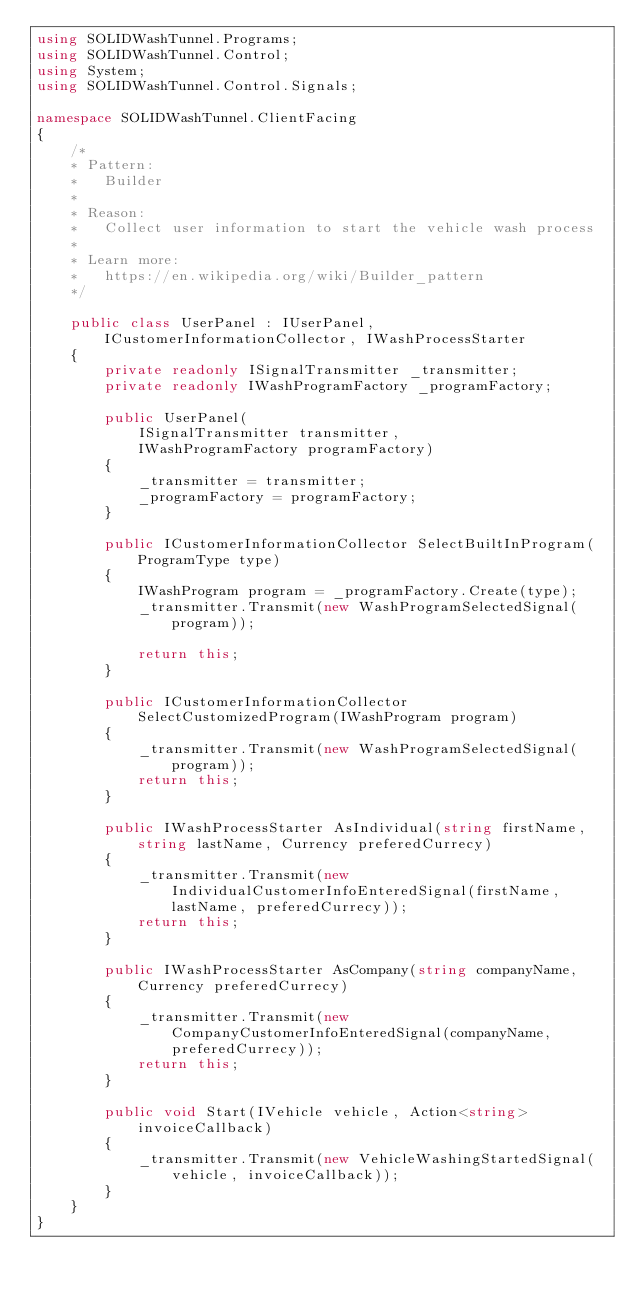<code> <loc_0><loc_0><loc_500><loc_500><_C#_>using SOLIDWashTunnel.Programs;
using SOLIDWashTunnel.Control;
using System;
using SOLIDWashTunnel.Control.Signals;

namespace SOLIDWashTunnel.ClientFacing
{
    /* 
    * Pattern:
    *   Builder
    *   
    * Reason: 
    *   Collect user information to start the vehicle wash process
    *   
    * Learn more: 
    *   https://en.wikipedia.org/wiki/Builder_pattern
    */

    public class UserPanel : IUserPanel, ICustomerInformationCollector, IWashProcessStarter
    {
        private readonly ISignalTransmitter _transmitter;
        private readonly IWashProgramFactory _programFactory;

        public UserPanel(
            ISignalTransmitter transmitter,
            IWashProgramFactory programFactory)
        {
            _transmitter = transmitter;
            _programFactory = programFactory;
        }

        public ICustomerInformationCollector SelectBuiltInProgram(ProgramType type)
        {
            IWashProgram program = _programFactory.Create(type);
            _transmitter.Transmit(new WashProgramSelectedSignal(program));

            return this;
        }

        public ICustomerInformationCollector SelectCustomizedProgram(IWashProgram program)
        {
            _transmitter.Transmit(new WashProgramSelectedSignal(program));
            return this;
        }

        public IWashProcessStarter AsIndividual(string firstName, string lastName, Currency preferedCurrecy)
        {
            _transmitter.Transmit(new IndividualCustomerInfoEnteredSignal(firstName, lastName, preferedCurrecy));
            return this;
        }

        public IWashProcessStarter AsCompany(string companyName, Currency preferedCurrecy)
        {
            _transmitter.Transmit(new CompanyCustomerInfoEnteredSignal(companyName, preferedCurrecy));
            return this;
        }

        public void Start(IVehicle vehicle, Action<string> invoiceCallback)
        {
            _transmitter.Transmit(new VehicleWashingStartedSignal(vehicle, invoiceCallback));
        }
    }
}
</code> 